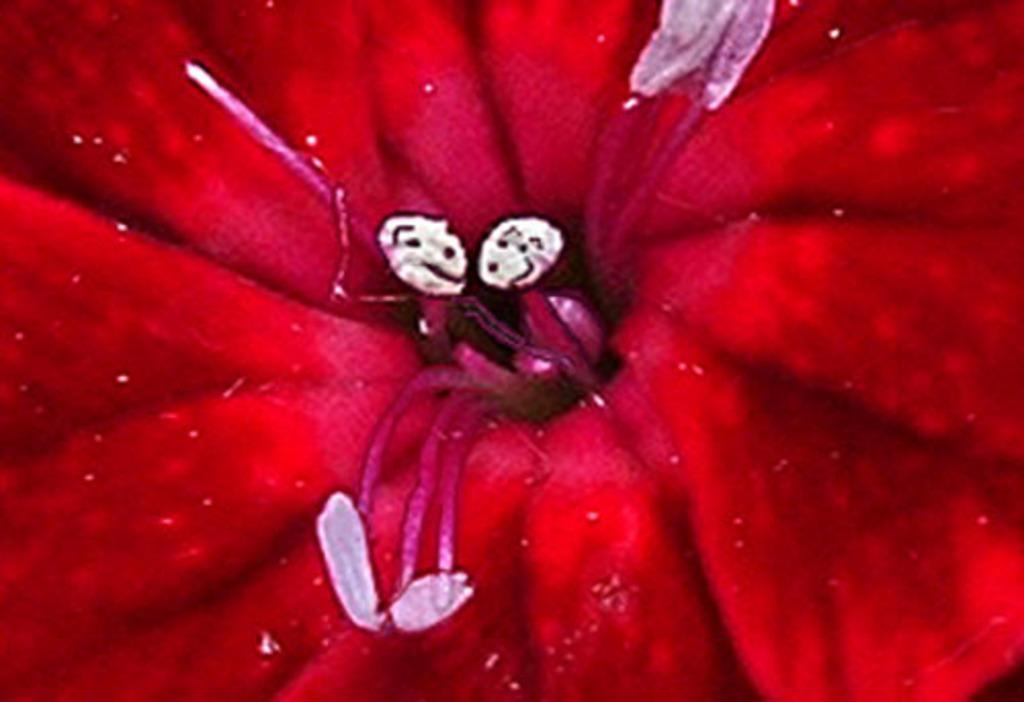Could you give a brief overview of what you see in this image? In this picture I can see red color flower. 